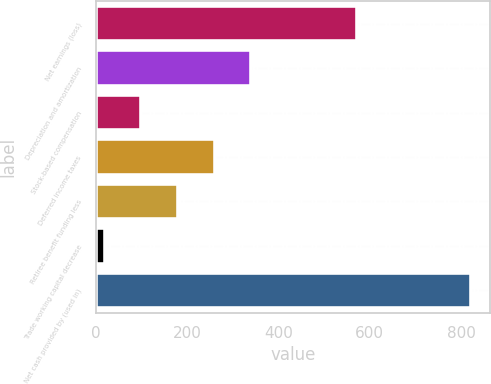<chart> <loc_0><loc_0><loc_500><loc_500><bar_chart><fcel>Net earnings (loss)<fcel>Depreciation and amortization<fcel>Stock-based compensation<fcel>Deferred income taxes<fcel>Retiree benefit funding less<fcel>Trade working capital decrease<fcel>Net cash provided by (used in)<nl><fcel>573<fcel>340.2<fcel>99.3<fcel>259.9<fcel>179.6<fcel>19<fcel>822<nl></chart> 